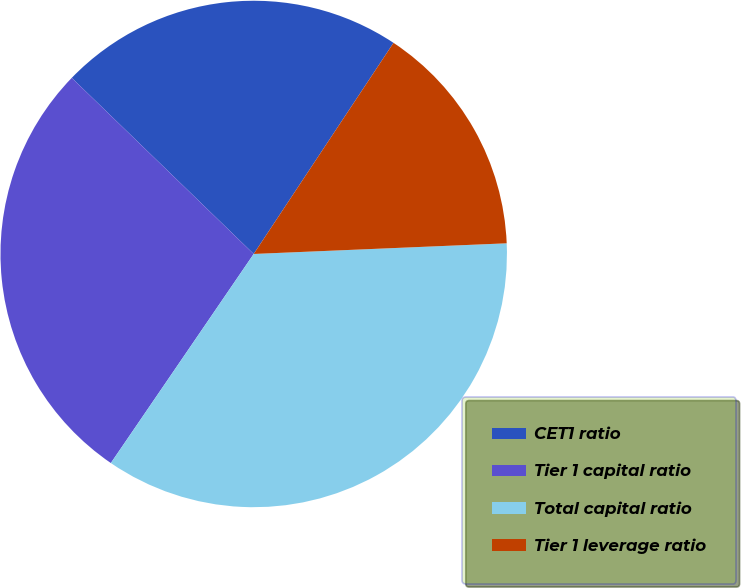<chart> <loc_0><loc_0><loc_500><loc_500><pie_chart><fcel>CET1 ratio<fcel>Tier 1 capital ratio<fcel>Total capital ratio<fcel>Tier 1 leverage ratio<nl><fcel>22.07%<fcel>27.7%<fcel>35.21%<fcel>15.02%<nl></chart> 